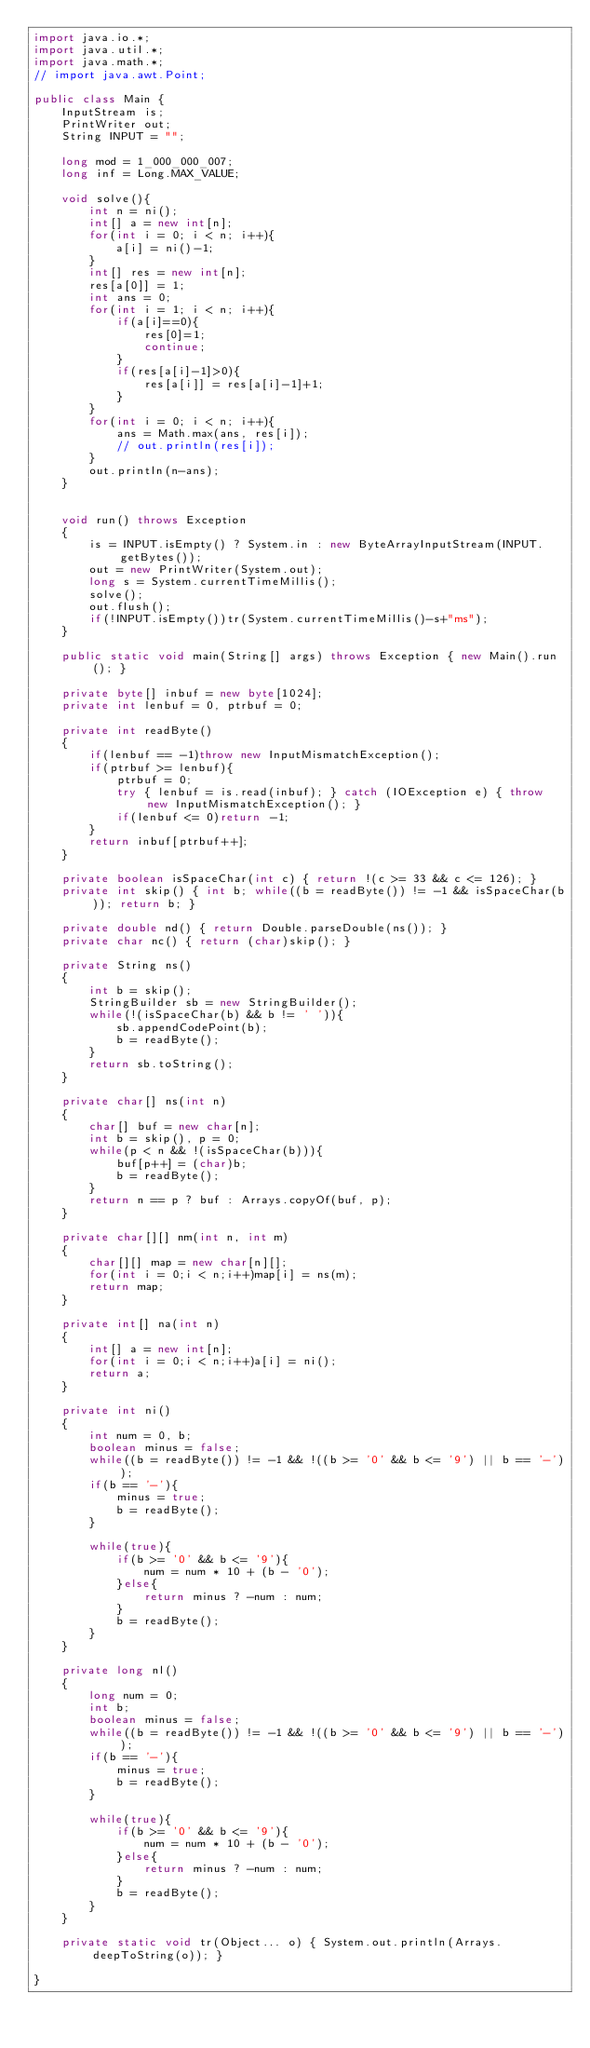<code> <loc_0><loc_0><loc_500><loc_500><_Java_>import java.io.*;
import java.util.*;
import java.math.*;
// import java.awt.Point;
 
public class Main {
    InputStream is;
    PrintWriter out;
    String INPUT = "";
 
    long mod = 1_000_000_007;
    long inf = Long.MAX_VALUE;

    void solve(){
        int n = ni();
        int[] a = new int[n];
        for(int i = 0; i < n; i++){
            a[i] = ni()-1;
        }
        int[] res = new int[n];
        res[a[0]] = 1;
        int ans = 0;
        for(int i = 1; i < n; i++){
            if(a[i]==0){
                res[0]=1;
                continue;
            }
            if(res[a[i]-1]>0){
                res[a[i]] = res[a[i]-1]+1;
            }
        }
        for(int i = 0; i < n; i++){
            ans = Math.max(ans, res[i]);
            // out.println(res[i]);
        }
        out.println(n-ans);
    }


    void run() throws Exception
    {
        is = INPUT.isEmpty() ? System.in : new ByteArrayInputStream(INPUT.getBytes());
        out = new PrintWriter(System.out);
        long s = System.currentTimeMillis();
        solve();
        out.flush();
        if(!INPUT.isEmpty())tr(System.currentTimeMillis()-s+"ms");
    }
    
    public static void main(String[] args) throws Exception { new Main().run(); }
    
    private byte[] inbuf = new byte[1024];
    private int lenbuf = 0, ptrbuf = 0;
    
    private int readByte()
    {
        if(lenbuf == -1)throw new InputMismatchException();
        if(ptrbuf >= lenbuf){
            ptrbuf = 0;
            try { lenbuf = is.read(inbuf); } catch (IOException e) { throw new InputMismatchException(); }
            if(lenbuf <= 0)return -1;
        }
        return inbuf[ptrbuf++];
    }
    
    private boolean isSpaceChar(int c) { return !(c >= 33 && c <= 126); }
    private int skip() { int b; while((b = readByte()) != -1 && isSpaceChar(b)); return b; }
    
    private double nd() { return Double.parseDouble(ns()); }
    private char nc() { return (char)skip(); }
    
    private String ns()
    {
        int b = skip();
        StringBuilder sb = new StringBuilder();
        while(!(isSpaceChar(b) && b != ' ')){
            sb.appendCodePoint(b);
            b = readByte();
        }
        return sb.toString();
    }
    
    private char[] ns(int n)
    {
        char[] buf = new char[n];
        int b = skip(), p = 0;
        while(p < n && !(isSpaceChar(b))){
            buf[p++] = (char)b;
            b = readByte();
        }
        return n == p ? buf : Arrays.copyOf(buf, p);
    }
    
    private char[][] nm(int n, int m)
    {
        char[][] map = new char[n][];
        for(int i = 0;i < n;i++)map[i] = ns(m);
        return map;
    }
    
    private int[] na(int n)
    {
        int[] a = new int[n];
        for(int i = 0;i < n;i++)a[i] = ni();
        return a;
    }
    
    private int ni()
    {
        int num = 0, b;
        boolean minus = false;
        while((b = readByte()) != -1 && !((b >= '0' && b <= '9') || b == '-'));
        if(b == '-'){
            minus = true;
            b = readByte();
        }
        
        while(true){
            if(b >= '0' && b <= '9'){
                num = num * 10 + (b - '0');
            }else{
                return minus ? -num : num;
            }
            b = readByte();
        }
    }
    
    private long nl()
    {
        long num = 0;
        int b;
        boolean minus = false;
        while((b = readByte()) != -1 && !((b >= '0' && b <= '9') || b == '-'));
        if(b == '-'){
            minus = true;
            b = readByte();
        }
        
        while(true){
            if(b >= '0' && b <= '9'){
                num = num * 10 + (b - '0');
            }else{
                return minus ? -num : num;
            }
            b = readByte();
        }
    }
    
    private static void tr(Object... o) { System.out.println(Arrays.deepToString(o)); }
 
}
</code> 